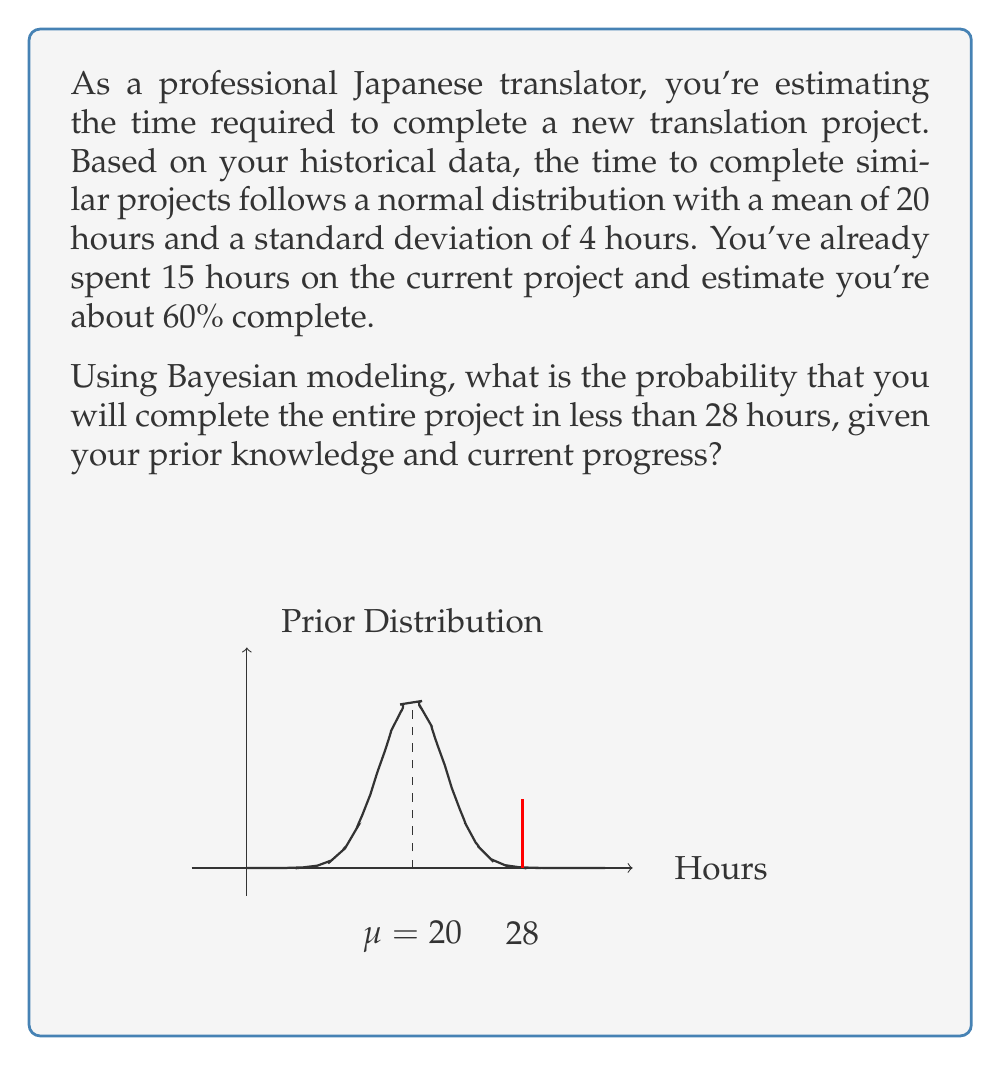Give your solution to this math problem. Let's approach this step-by-step using Bayesian modeling:

1) First, we need to update our prior belief based on the current progress:

   - Prior mean ($\mu_0$) = 20 hours
   - Prior standard deviation ($\sigma_0$) = 4 hours
   - Observed data: 15 hours for 60% completion

2) We can estimate the total time based on current progress:

   $\text{Estimated total time} = \frac{15}{0.6} = 25$ hours

3) Now, we need to combine our prior belief with this new information. We'll use the following Bayesian update formulas:

   $$\mu_1 = \frac{\sigma_0^2 \cdot 25 + \sigma_1^2 \cdot \mu_0}{\sigma_0^2 + \sigma_1^2}$$
   $$\frac{1}{\sigma_1^2} = \frac{1}{\sigma_0^2} + \frac{1}{\sigma_2^2}$$

   Where $\sigma_1$ is our posterior standard deviation and $\sigma_2$ is the standard deviation of our new estimate.

4) We need to estimate $\sigma_2$. Given that 15 hours is 60% of the project, we can estimate:

   $\sigma_2 \approx \frac{4}{\sqrt{0.6}} \approx 5.16$ hours

5) Now we can calculate our posterior parameters:

   $$\frac{1}{\sigma_1^2} = \frac{1}{4^2} + \frac{1}{5.16^2} \approx 0.0781$$
   $$\sigma_1 \approx 3.58$$

   $$\mu_1 = \frac{4^2 \cdot 25 + 3.58^2 \cdot 20}{4^2 + 3.58^2} \approx 22.65$$

6) Our updated belief about the project time is now normally distributed with mean 22.65 and standard deviation 3.58.

7) To find the probability of completing in less than 28 hours, we need to calculate the z-score:

   $$z = \frac{28 - 22.65}{3.58} \approx 1.49$$

8) Using a standard normal table or calculator, we can find the probability:

   $$P(X < 28) = \Phi(1.49) \approx 0.9319$$

Therefore, the probability of completing the project in less than 28 hours is approximately 0.9319 or 93.19%.
Answer: $0.9319$ or $93.19\%$ 